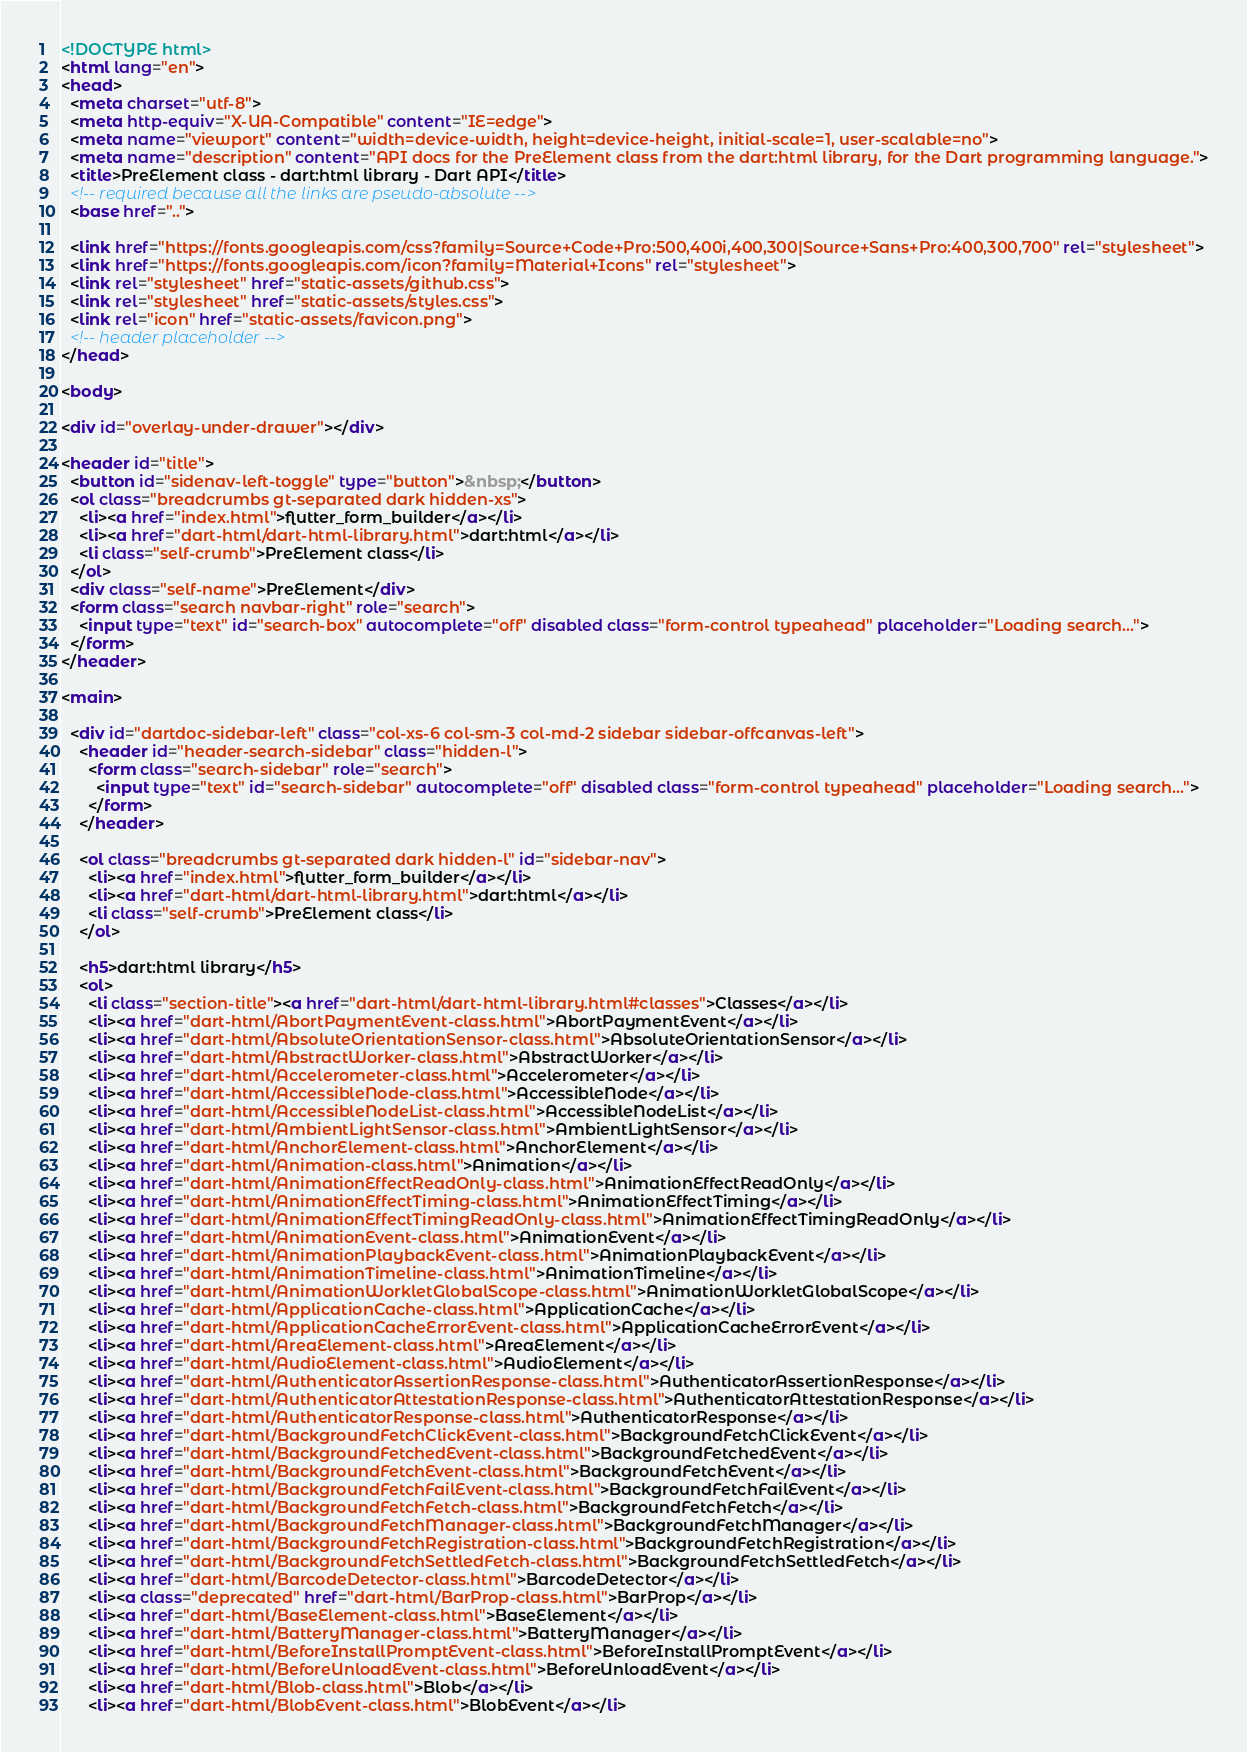Convert code to text. <code><loc_0><loc_0><loc_500><loc_500><_HTML_><!DOCTYPE html>
<html lang="en">
<head>
  <meta charset="utf-8">
  <meta http-equiv="X-UA-Compatible" content="IE=edge">
  <meta name="viewport" content="width=device-width, height=device-height, initial-scale=1, user-scalable=no">
  <meta name="description" content="API docs for the PreElement class from the dart:html library, for the Dart programming language.">
  <title>PreElement class - dart:html library - Dart API</title>
  <!-- required because all the links are pseudo-absolute -->
  <base href="..">

  <link href="https://fonts.googleapis.com/css?family=Source+Code+Pro:500,400i,400,300|Source+Sans+Pro:400,300,700" rel="stylesheet">
  <link href="https://fonts.googleapis.com/icon?family=Material+Icons" rel="stylesheet">
  <link rel="stylesheet" href="static-assets/github.css">
  <link rel="stylesheet" href="static-assets/styles.css">
  <link rel="icon" href="static-assets/favicon.png">
  <!-- header placeholder -->
</head>

<body>

<div id="overlay-under-drawer"></div>

<header id="title">
  <button id="sidenav-left-toggle" type="button">&nbsp;</button>
  <ol class="breadcrumbs gt-separated dark hidden-xs">
    <li><a href="index.html">flutter_form_builder</a></li>
    <li><a href="dart-html/dart-html-library.html">dart:html</a></li>
    <li class="self-crumb">PreElement class</li>
  </ol>
  <div class="self-name">PreElement</div>
  <form class="search navbar-right" role="search">
    <input type="text" id="search-box" autocomplete="off" disabled class="form-control typeahead" placeholder="Loading search...">
  </form>
</header>

<main>

  <div id="dartdoc-sidebar-left" class="col-xs-6 col-sm-3 col-md-2 sidebar sidebar-offcanvas-left">
    <header id="header-search-sidebar" class="hidden-l">
      <form class="search-sidebar" role="search">
        <input type="text" id="search-sidebar" autocomplete="off" disabled class="form-control typeahead" placeholder="Loading search...">
      </form>
    </header>
    
    <ol class="breadcrumbs gt-separated dark hidden-l" id="sidebar-nav">
      <li><a href="index.html">flutter_form_builder</a></li>
      <li><a href="dart-html/dart-html-library.html">dart:html</a></li>
      <li class="self-crumb">PreElement class</li>
    </ol>
    
    <h5>dart:html library</h5>
    <ol>
      <li class="section-title"><a href="dart-html/dart-html-library.html#classes">Classes</a></li>
      <li><a href="dart-html/AbortPaymentEvent-class.html">AbortPaymentEvent</a></li>
      <li><a href="dart-html/AbsoluteOrientationSensor-class.html">AbsoluteOrientationSensor</a></li>
      <li><a href="dart-html/AbstractWorker-class.html">AbstractWorker</a></li>
      <li><a href="dart-html/Accelerometer-class.html">Accelerometer</a></li>
      <li><a href="dart-html/AccessibleNode-class.html">AccessibleNode</a></li>
      <li><a href="dart-html/AccessibleNodeList-class.html">AccessibleNodeList</a></li>
      <li><a href="dart-html/AmbientLightSensor-class.html">AmbientLightSensor</a></li>
      <li><a href="dart-html/AnchorElement-class.html">AnchorElement</a></li>
      <li><a href="dart-html/Animation-class.html">Animation</a></li>
      <li><a href="dart-html/AnimationEffectReadOnly-class.html">AnimationEffectReadOnly</a></li>
      <li><a href="dart-html/AnimationEffectTiming-class.html">AnimationEffectTiming</a></li>
      <li><a href="dart-html/AnimationEffectTimingReadOnly-class.html">AnimationEffectTimingReadOnly</a></li>
      <li><a href="dart-html/AnimationEvent-class.html">AnimationEvent</a></li>
      <li><a href="dart-html/AnimationPlaybackEvent-class.html">AnimationPlaybackEvent</a></li>
      <li><a href="dart-html/AnimationTimeline-class.html">AnimationTimeline</a></li>
      <li><a href="dart-html/AnimationWorkletGlobalScope-class.html">AnimationWorkletGlobalScope</a></li>
      <li><a href="dart-html/ApplicationCache-class.html">ApplicationCache</a></li>
      <li><a href="dart-html/ApplicationCacheErrorEvent-class.html">ApplicationCacheErrorEvent</a></li>
      <li><a href="dart-html/AreaElement-class.html">AreaElement</a></li>
      <li><a href="dart-html/AudioElement-class.html">AudioElement</a></li>
      <li><a href="dart-html/AuthenticatorAssertionResponse-class.html">AuthenticatorAssertionResponse</a></li>
      <li><a href="dart-html/AuthenticatorAttestationResponse-class.html">AuthenticatorAttestationResponse</a></li>
      <li><a href="dart-html/AuthenticatorResponse-class.html">AuthenticatorResponse</a></li>
      <li><a href="dart-html/BackgroundFetchClickEvent-class.html">BackgroundFetchClickEvent</a></li>
      <li><a href="dart-html/BackgroundFetchedEvent-class.html">BackgroundFetchedEvent</a></li>
      <li><a href="dart-html/BackgroundFetchEvent-class.html">BackgroundFetchEvent</a></li>
      <li><a href="dart-html/BackgroundFetchFailEvent-class.html">BackgroundFetchFailEvent</a></li>
      <li><a href="dart-html/BackgroundFetchFetch-class.html">BackgroundFetchFetch</a></li>
      <li><a href="dart-html/BackgroundFetchManager-class.html">BackgroundFetchManager</a></li>
      <li><a href="dart-html/BackgroundFetchRegistration-class.html">BackgroundFetchRegistration</a></li>
      <li><a href="dart-html/BackgroundFetchSettledFetch-class.html">BackgroundFetchSettledFetch</a></li>
      <li><a href="dart-html/BarcodeDetector-class.html">BarcodeDetector</a></li>
      <li><a class="deprecated" href="dart-html/BarProp-class.html">BarProp</a></li>
      <li><a href="dart-html/BaseElement-class.html">BaseElement</a></li>
      <li><a href="dart-html/BatteryManager-class.html">BatteryManager</a></li>
      <li><a href="dart-html/BeforeInstallPromptEvent-class.html">BeforeInstallPromptEvent</a></li>
      <li><a href="dart-html/BeforeUnloadEvent-class.html">BeforeUnloadEvent</a></li>
      <li><a href="dart-html/Blob-class.html">Blob</a></li>
      <li><a href="dart-html/BlobEvent-class.html">BlobEvent</a></li></code> 